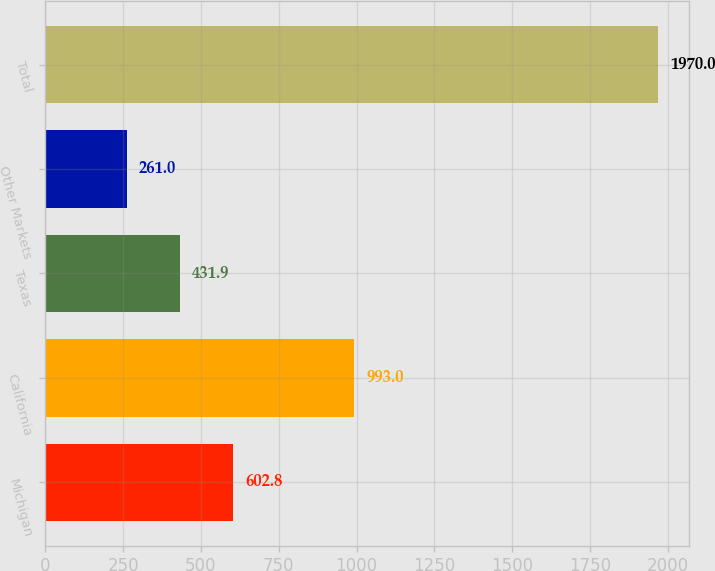Convert chart. <chart><loc_0><loc_0><loc_500><loc_500><bar_chart><fcel>Michigan<fcel>California<fcel>Texas<fcel>Other Markets<fcel>Total<nl><fcel>602.8<fcel>993<fcel>431.9<fcel>261<fcel>1970<nl></chart> 